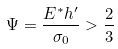Convert formula to latex. <formula><loc_0><loc_0><loc_500><loc_500>\Psi = \frac { E ^ { * } h ^ { \prime } } { \sigma _ { 0 } } > \frac { 2 } { 3 }</formula> 